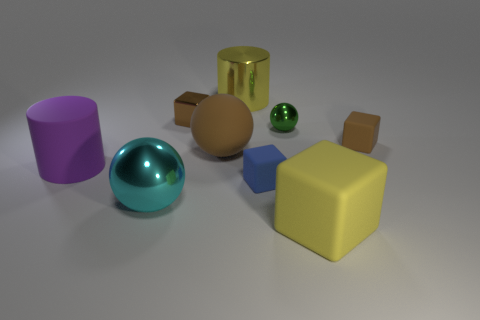Add 1 small brown metallic cubes. How many objects exist? 10 Subtract all metallic spheres. How many spheres are left? 1 Subtract all cubes. How many objects are left? 5 Subtract all blue balls. How many brown cubes are left? 2 Subtract all brown cubes. How many cubes are left? 2 Subtract 0 gray cylinders. How many objects are left? 9 Subtract 3 spheres. How many spheres are left? 0 Subtract all green cubes. Subtract all blue spheres. How many cubes are left? 4 Subtract all tiny blue things. Subtract all big cyan things. How many objects are left? 7 Add 9 tiny metallic blocks. How many tiny metallic blocks are left? 10 